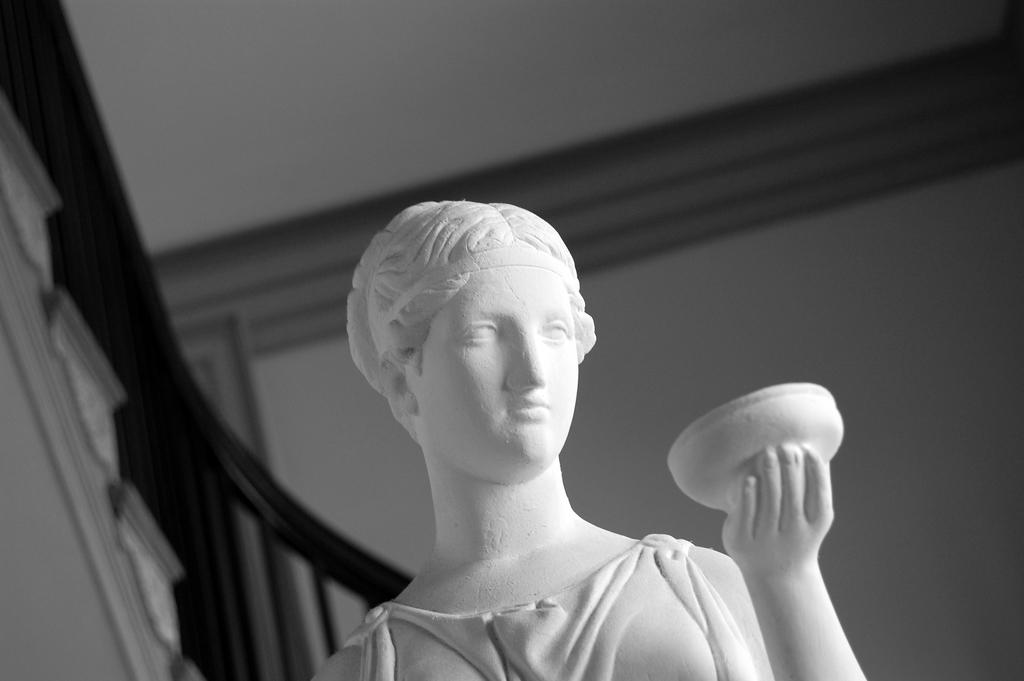What is the color scheme of the image? The image is black and white. What can be seen in the image besides the stairs and railing? There is a statue of a person in the image. What architectural feature is present on the left side of the image? There are stairs on the left side of the image. What safety feature is associated with the stairs? There is railing associated with the stairs. What is visible in the background of the image? There is a wall in the background of the image. What type of balls are being used for the discussion in the image? There are no balls or discussions present in the image; it features a statue, stairs, railing, and a wall. What material is used to cover the statue in the image? There is no mention of any covering on the statue in the image; it appears to be uncovered. 